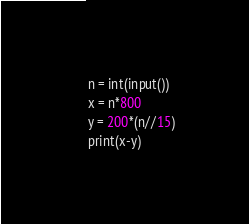Convert code to text. <code><loc_0><loc_0><loc_500><loc_500><_Python_>n = int(input())
x = n*800
y = 200*(n//15)
print(x-y)
</code> 